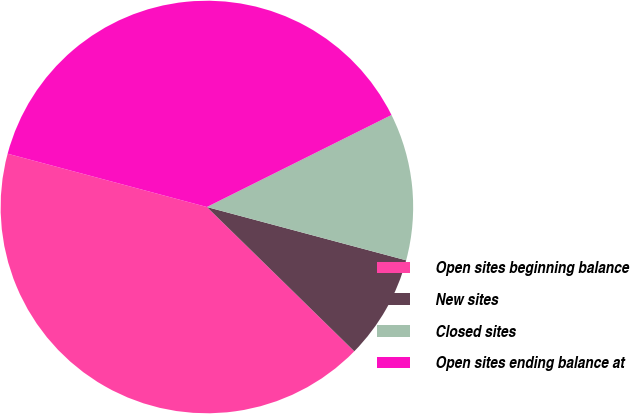<chart> <loc_0><loc_0><loc_500><loc_500><pie_chart><fcel>Open sites beginning balance<fcel>New sites<fcel>Closed sites<fcel>Open sites ending balance at<nl><fcel>41.83%<fcel>8.17%<fcel>11.52%<fcel>38.48%<nl></chart> 